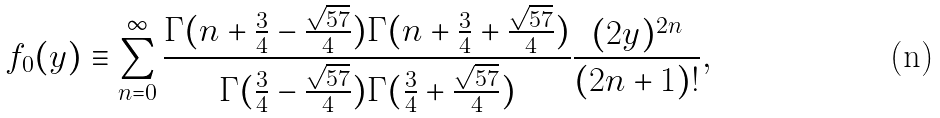Convert formula to latex. <formula><loc_0><loc_0><loc_500><loc_500>f _ { 0 } ( y ) \equiv \sum _ { n = 0 } ^ { \infty } \frac { \Gamma ( n + \frac { 3 } { 4 } - \frac { \sqrt { 5 7 } } { 4 } ) \Gamma ( n + \frac { 3 } { 4 } + \frac { \sqrt { 5 7 } } { 4 } ) } { \Gamma ( \frac { 3 } { 4 } - \frac { \sqrt { 5 7 } } { 4 } ) \Gamma ( \frac { 3 } { 4 } + \frac { \sqrt { 5 7 } } { 4 } ) } \frac { ( 2 y ) ^ { 2 n } } { ( 2 n + 1 ) ! } ,</formula> 